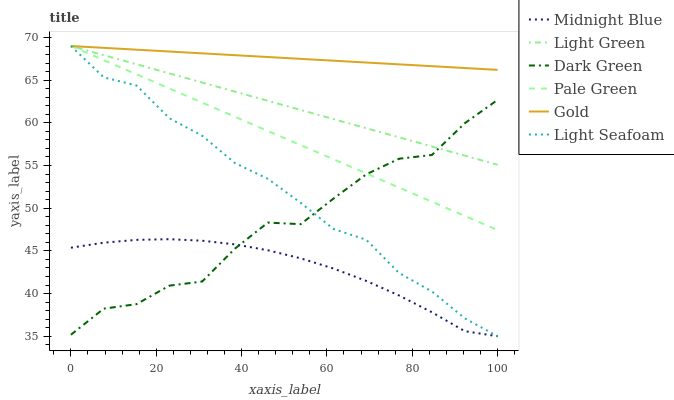Does Midnight Blue have the minimum area under the curve?
Answer yes or no. Yes. Does Gold have the maximum area under the curve?
Answer yes or no. Yes. Does Pale Green have the minimum area under the curve?
Answer yes or no. No. Does Pale Green have the maximum area under the curve?
Answer yes or no. No. Is Light Green the smoothest?
Answer yes or no. Yes. Is Dark Green the roughest?
Answer yes or no. Yes. Is Gold the smoothest?
Answer yes or no. No. Is Gold the roughest?
Answer yes or no. No. Does Midnight Blue have the lowest value?
Answer yes or no. Yes. Does Pale Green have the lowest value?
Answer yes or no. No. Does Light Seafoam have the highest value?
Answer yes or no. Yes. Does Dark Green have the highest value?
Answer yes or no. No. Is Midnight Blue less than Gold?
Answer yes or no. Yes. Is Gold greater than Dark Green?
Answer yes or no. Yes. Does Gold intersect Light Green?
Answer yes or no. Yes. Is Gold less than Light Green?
Answer yes or no. No. Is Gold greater than Light Green?
Answer yes or no. No. Does Midnight Blue intersect Gold?
Answer yes or no. No. 